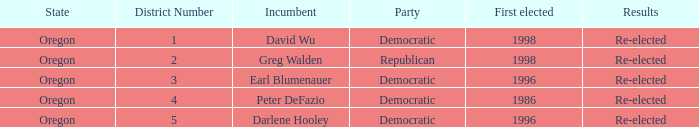Which Democratic incumbent was first elected in 1998? David Wu. 